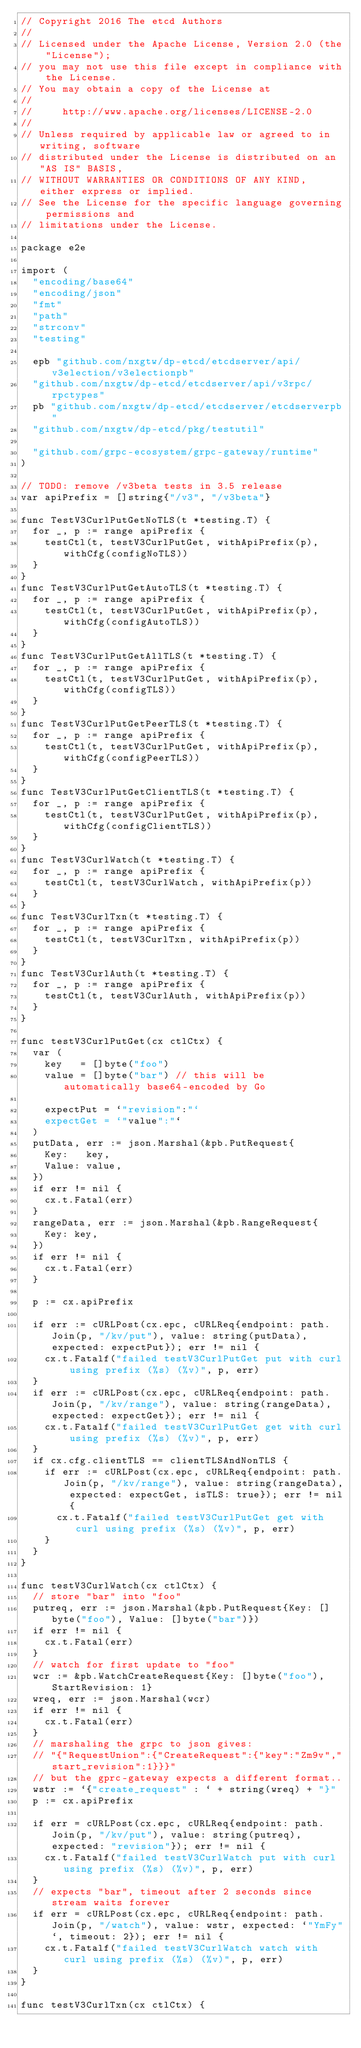<code> <loc_0><loc_0><loc_500><loc_500><_Go_>// Copyright 2016 The etcd Authors
//
// Licensed under the Apache License, Version 2.0 (the "License");
// you may not use this file except in compliance with the License.
// You may obtain a copy of the License at
//
//     http://www.apache.org/licenses/LICENSE-2.0
//
// Unless required by applicable law or agreed to in writing, software
// distributed under the License is distributed on an "AS IS" BASIS,
// WITHOUT WARRANTIES OR CONDITIONS OF ANY KIND, either express or implied.
// See the License for the specific language governing permissions and
// limitations under the License.

package e2e

import (
	"encoding/base64"
	"encoding/json"
	"fmt"
	"path"
	"strconv"
	"testing"

	epb "github.com/nxgtw/dp-etcd/etcdserver/api/v3election/v3electionpb"
	"github.com/nxgtw/dp-etcd/etcdserver/api/v3rpc/rpctypes"
	pb "github.com/nxgtw/dp-etcd/etcdserver/etcdserverpb"
	"github.com/nxgtw/dp-etcd/pkg/testutil"

	"github.com/grpc-ecosystem/grpc-gateway/runtime"
)

// TODO: remove /v3beta tests in 3.5 release
var apiPrefix = []string{"/v3", "/v3beta"}

func TestV3CurlPutGetNoTLS(t *testing.T) {
	for _, p := range apiPrefix {
		testCtl(t, testV3CurlPutGet, withApiPrefix(p), withCfg(configNoTLS))
	}
}
func TestV3CurlPutGetAutoTLS(t *testing.T) {
	for _, p := range apiPrefix {
		testCtl(t, testV3CurlPutGet, withApiPrefix(p), withCfg(configAutoTLS))
	}
}
func TestV3CurlPutGetAllTLS(t *testing.T) {
	for _, p := range apiPrefix {
		testCtl(t, testV3CurlPutGet, withApiPrefix(p), withCfg(configTLS))
	}
}
func TestV3CurlPutGetPeerTLS(t *testing.T) {
	for _, p := range apiPrefix {
		testCtl(t, testV3CurlPutGet, withApiPrefix(p), withCfg(configPeerTLS))
	}
}
func TestV3CurlPutGetClientTLS(t *testing.T) {
	for _, p := range apiPrefix {
		testCtl(t, testV3CurlPutGet, withApiPrefix(p), withCfg(configClientTLS))
	}
}
func TestV3CurlWatch(t *testing.T) {
	for _, p := range apiPrefix {
		testCtl(t, testV3CurlWatch, withApiPrefix(p))
	}
}
func TestV3CurlTxn(t *testing.T) {
	for _, p := range apiPrefix {
		testCtl(t, testV3CurlTxn, withApiPrefix(p))
	}
}
func TestV3CurlAuth(t *testing.T) {
	for _, p := range apiPrefix {
		testCtl(t, testV3CurlAuth, withApiPrefix(p))
	}
}

func testV3CurlPutGet(cx ctlCtx) {
	var (
		key   = []byte("foo")
		value = []byte("bar") // this will be automatically base64-encoded by Go

		expectPut = `"revision":"`
		expectGet = `"value":"`
	)
	putData, err := json.Marshal(&pb.PutRequest{
		Key:   key,
		Value: value,
	})
	if err != nil {
		cx.t.Fatal(err)
	}
	rangeData, err := json.Marshal(&pb.RangeRequest{
		Key: key,
	})
	if err != nil {
		cx.t.Fatal(err)
	}

	p := cx.apiPrefix

	if err := cURLPost(cx.epc, cURLReq{endpoint: path.Join(p, "/kv/put"), value: string(putData), expected: expectPut}); err != nil {
		cx.t.Fatalf("failed testV3CurlPutGet put with curl using prefix (%s) (%v)", p, err)
	}
	if err := cURLPost(cx.epc, cURLReq{endpoint: path.Join(p, "/kv/range"), value: string(rangeData), expected: expectGet}); err != nil {
		cx.t.Fatalf("failed testV3CurlPutGet get with curl using prefix (%s) (%v)", p, err)
	}
	if cx.cfg.clientTLS == clientTLSAndNonTLS {
		if err := cURLPost(cx.epc, cURLReq{endpoint: path.Join(p, "/kv/range"), value: string(rangeData), expected: expectGet, isTLS: true}); err != nil {
			cx.t.Fatalf("failed testV3CurlPutGet get with curl using prefix (%s) (%v)", p, err)
		}
	}
}

func testV3CurlWatch(cx ctlCtx) {
	// store "bar" into "foo"
	putreq, err := json.Marshal(&pb.PutRequest{Key: []byte("foo"), Value: []byte("bar")})
	if err != nil {
		cx.t.Fatal(err)
	}
	// watch for first update to "foo"
	wcr := &pb.WatchCreateRequest{Key: []byte("foo"), StartRevision: 1}
	wreq, err := json.Marshal(wcr)
	if err != nil {
		cx.t.Fatal(err)
	}
	// marshaling the grpc to json gives:
	// "{"RequestUnion":{"CreateRequest":{"key":"Zm9v","start_revision":1}}}"
	// but the gprc-gateway expects a different format..
	wstr := `{"create_request" : ` + string(wreq) + "}"
	p := cx.apiPrefix

	if err = cURLPost(cx.epc, cURLReq{endpoint: path.Join(p, "/kv/put"), value: string(putreq), expected: "revision"}); err != nil {
		cx.t.Fatalf("failed testV3CurlWatch put with curl using prefix (%s) (%v)", p, err)
	}
	// expects "bar", timeout after 2 seconds since stream waits forever
	if err = cURLPost(cx.epc, cURLReq{endpoint: path.Join(p, "/watch"), value: wstr, expected: `"YmFy"`, timeout: 2}); err != nil {
		cx.t.Fatalf("failed testV3CurlWatch watch with curl using prefix (%s) (%v)", p, err)
	}
}

func testV3CurlTxn(cx ctlCtx) {</code> 